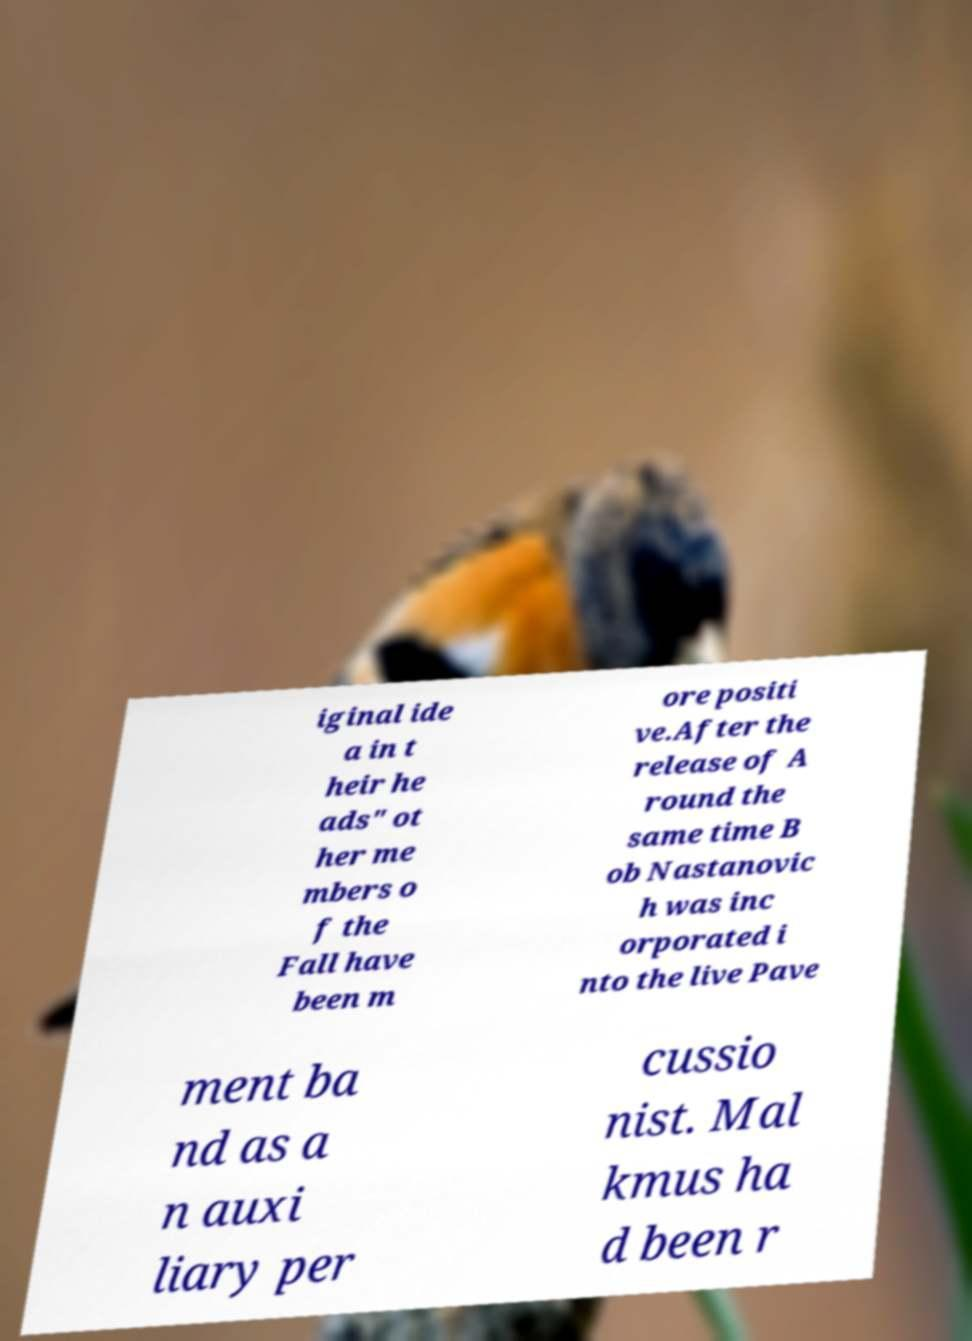Please read and relay the text visible in this image. What does it say? iginal ide a in t heir he ads" ot her me mbers o f the Fall have been m ore positi ve.After the release of A round the same time B ob Nastanovic h was inc orporated i nto the live Pave ment ba nd as a n auxi liary per cussio nist. Mal kmus ha d been r 